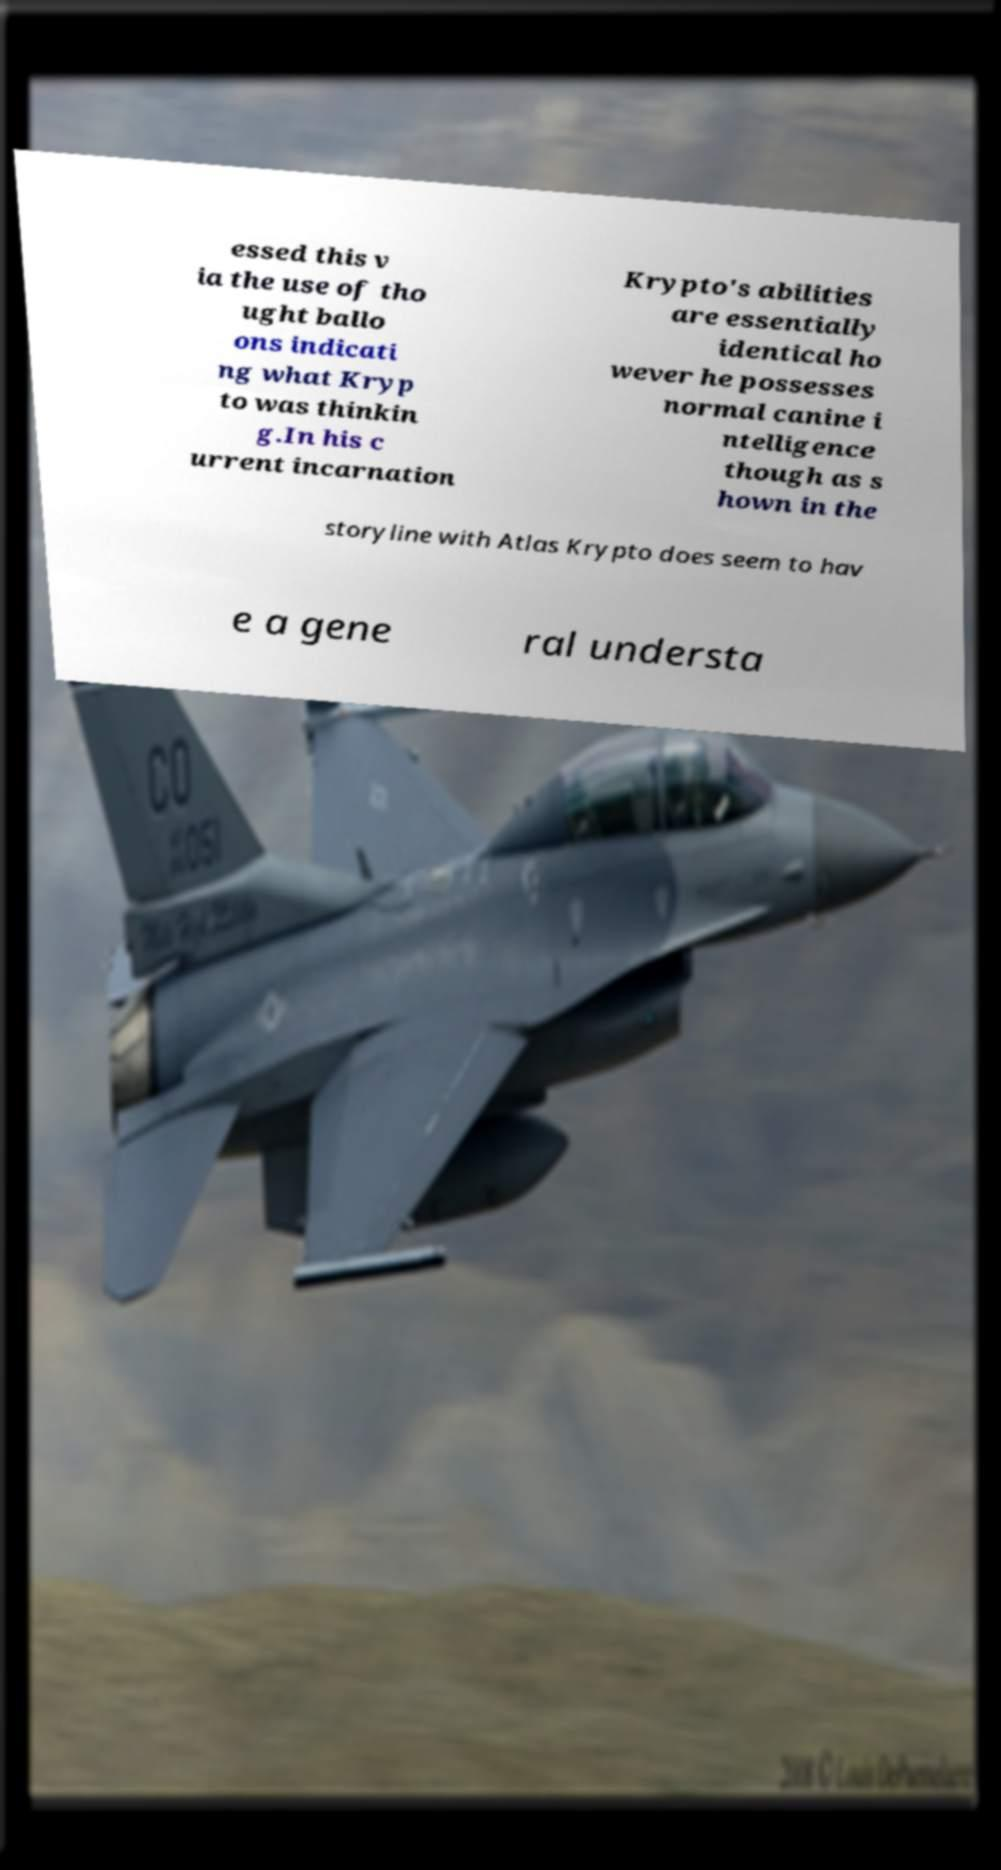Can you read and provide the text displayed in the image?This photo seems to have some interesting text. Can you extract and type it out for me? essed this v ia the use of tho ught ballo ons indicati ng what Kryp to was thinkin g.In his c urrent incarnation Krypto's abilities are essentially identical ho wever he possesses normal canine i ntelligence though as s hown in the storyline with Atlas Krypto does seem to hav e a gene ral understa 